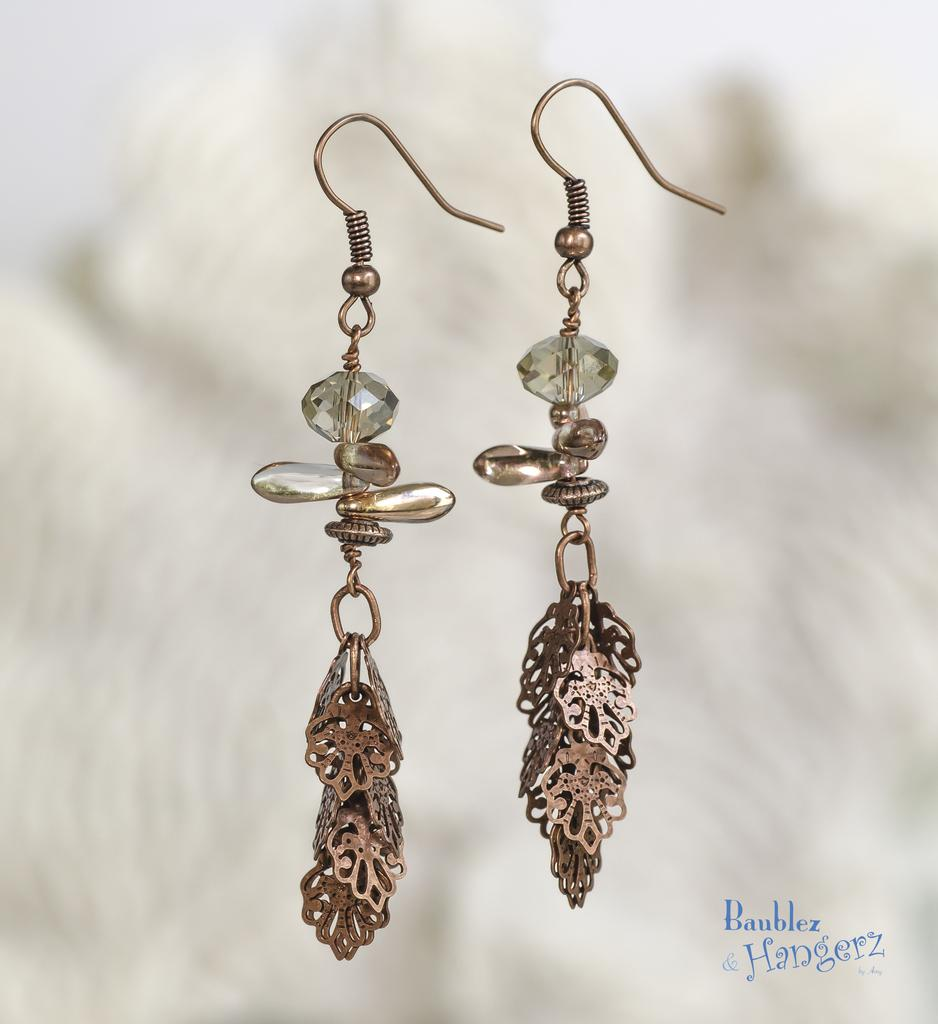What type of accessory is featured in the image? There is a pair of earrings in the image. Can you describe the background of the image? The background of the image is blurred. Is there any additional information or marking on the image? Yes, there is a watermark on the image. How many jellyfish can be seen swimming in the background of the image? There are no jellyfish present in the image; the background is blurred. 